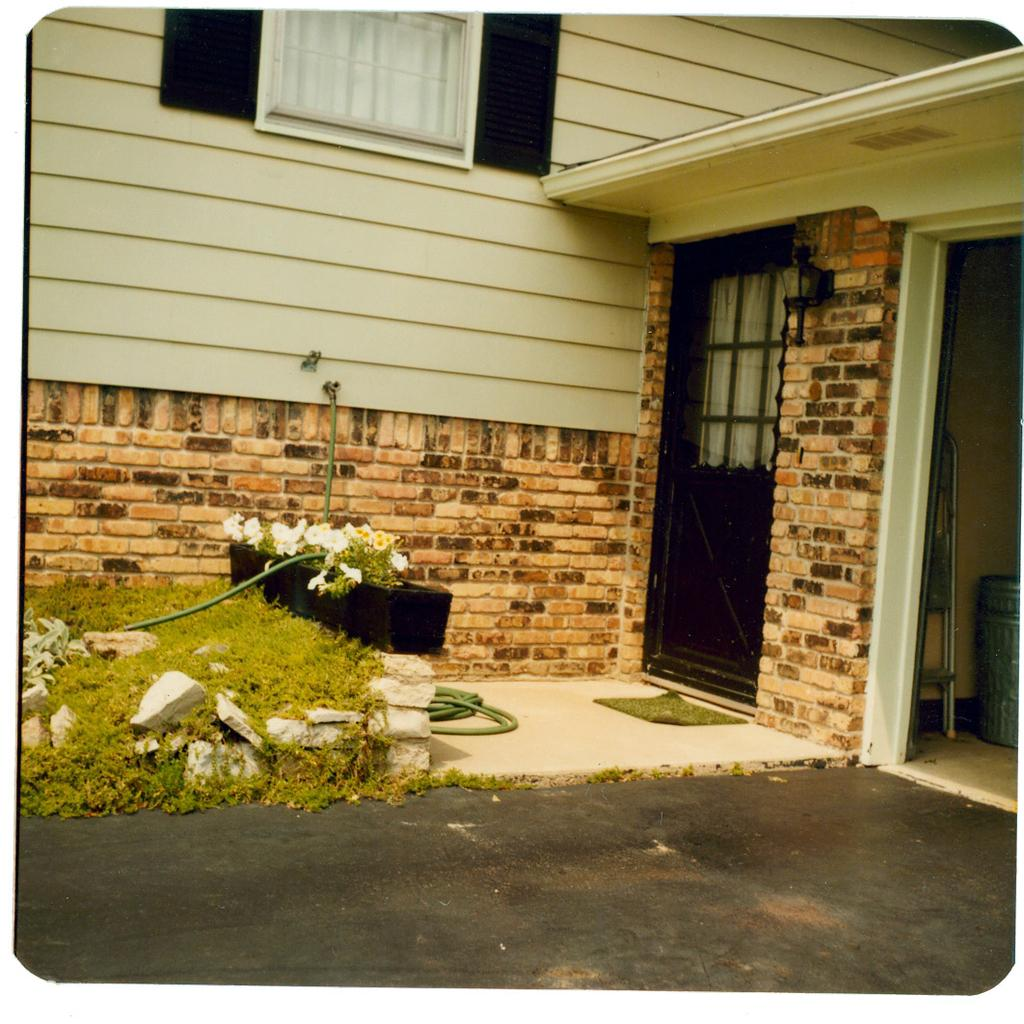What type of structure is present in the image? There is a building in the image. What features can be seen on the building? The building has windows and a door. What is placed in front of the building? There is a flower pot in front of the building. What type of ground cover is visible in the image? There are stones and grass visible in the image. What other objects can be seen in the image? There is a pipe and a mat in the image. What songs is the woman singing in the image? There is no woman present in the image, and therefore no singing can be observed. 